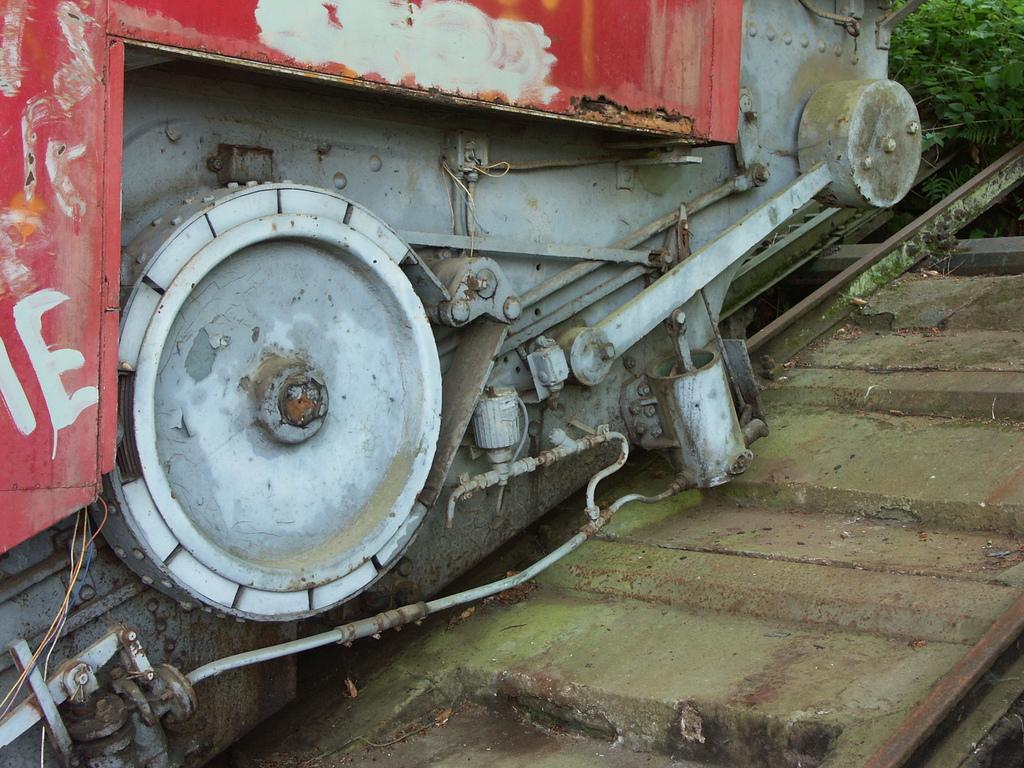Describe this image in one or two sentences. In this image I can see a part of a train which is on the railway track. In the top right I can see few plants. 